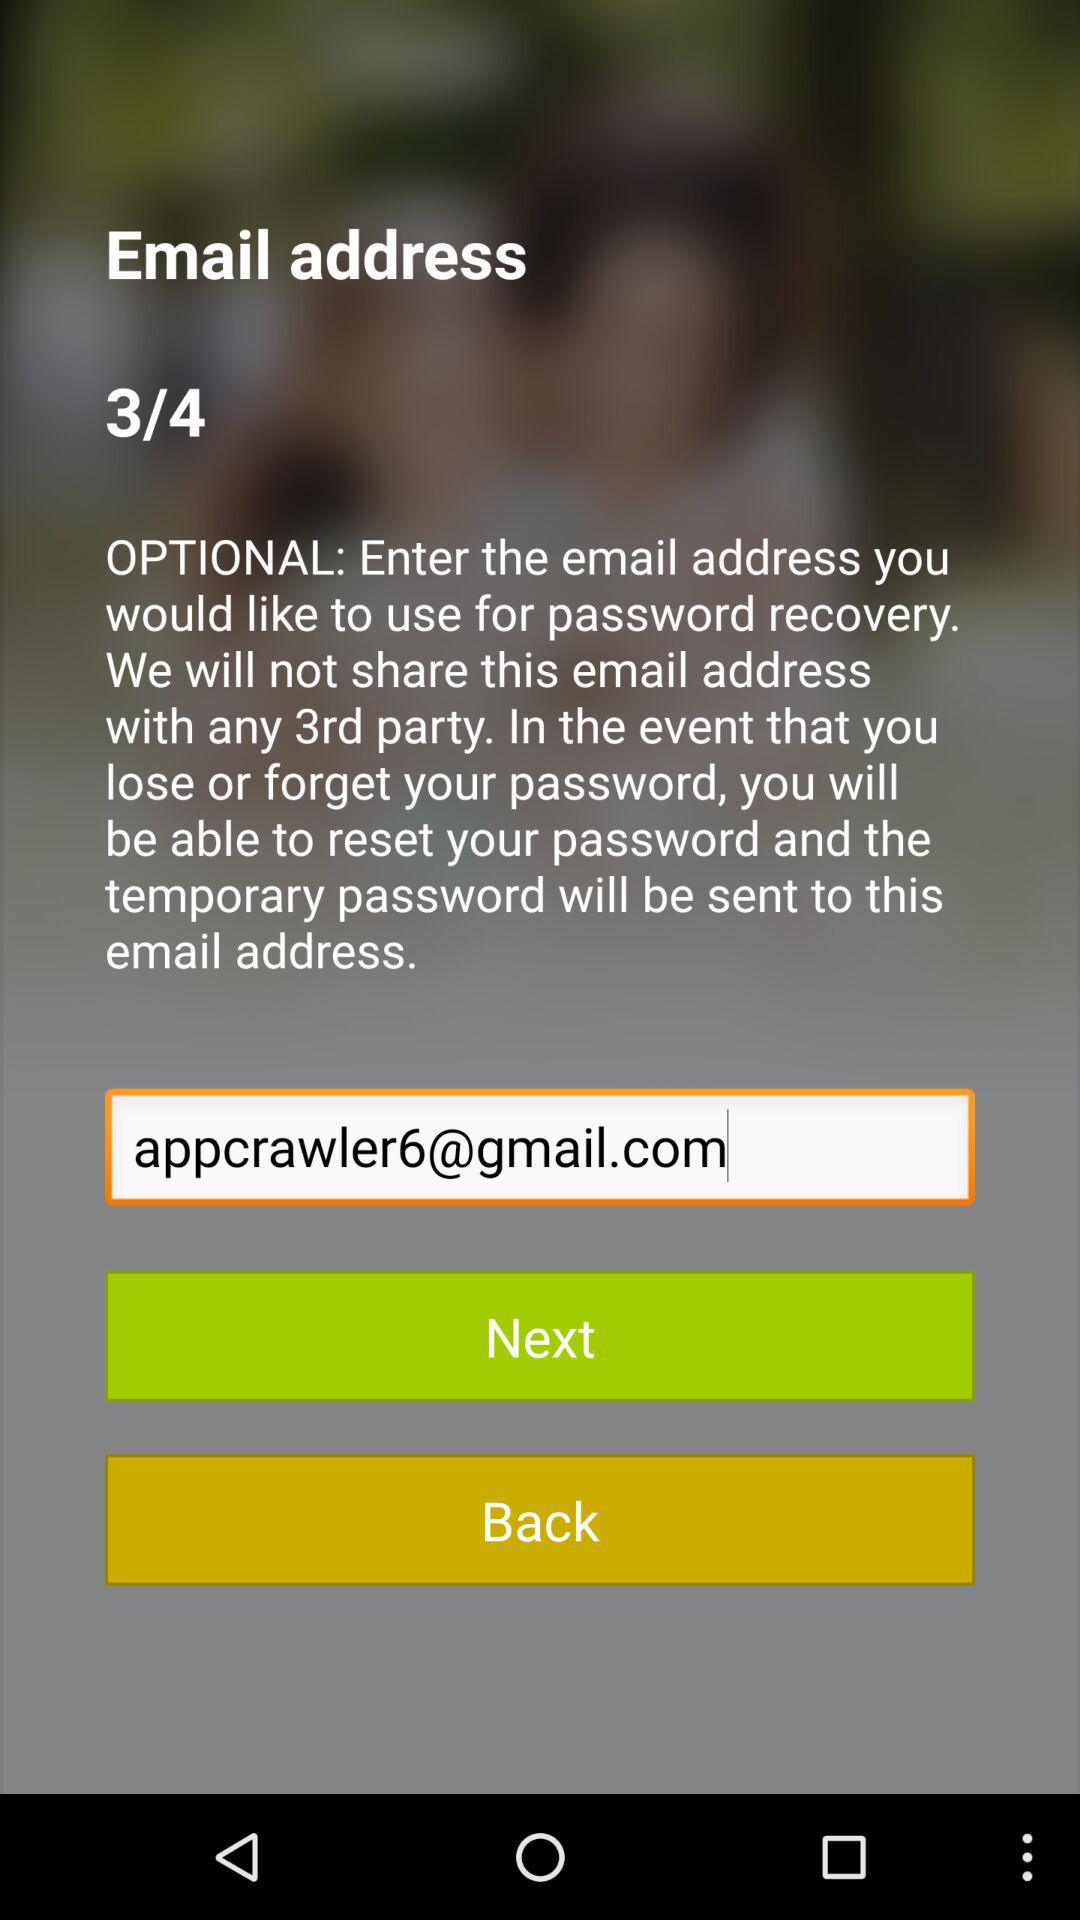What is the email address? The email address is appcrawler6@gmail.com. 